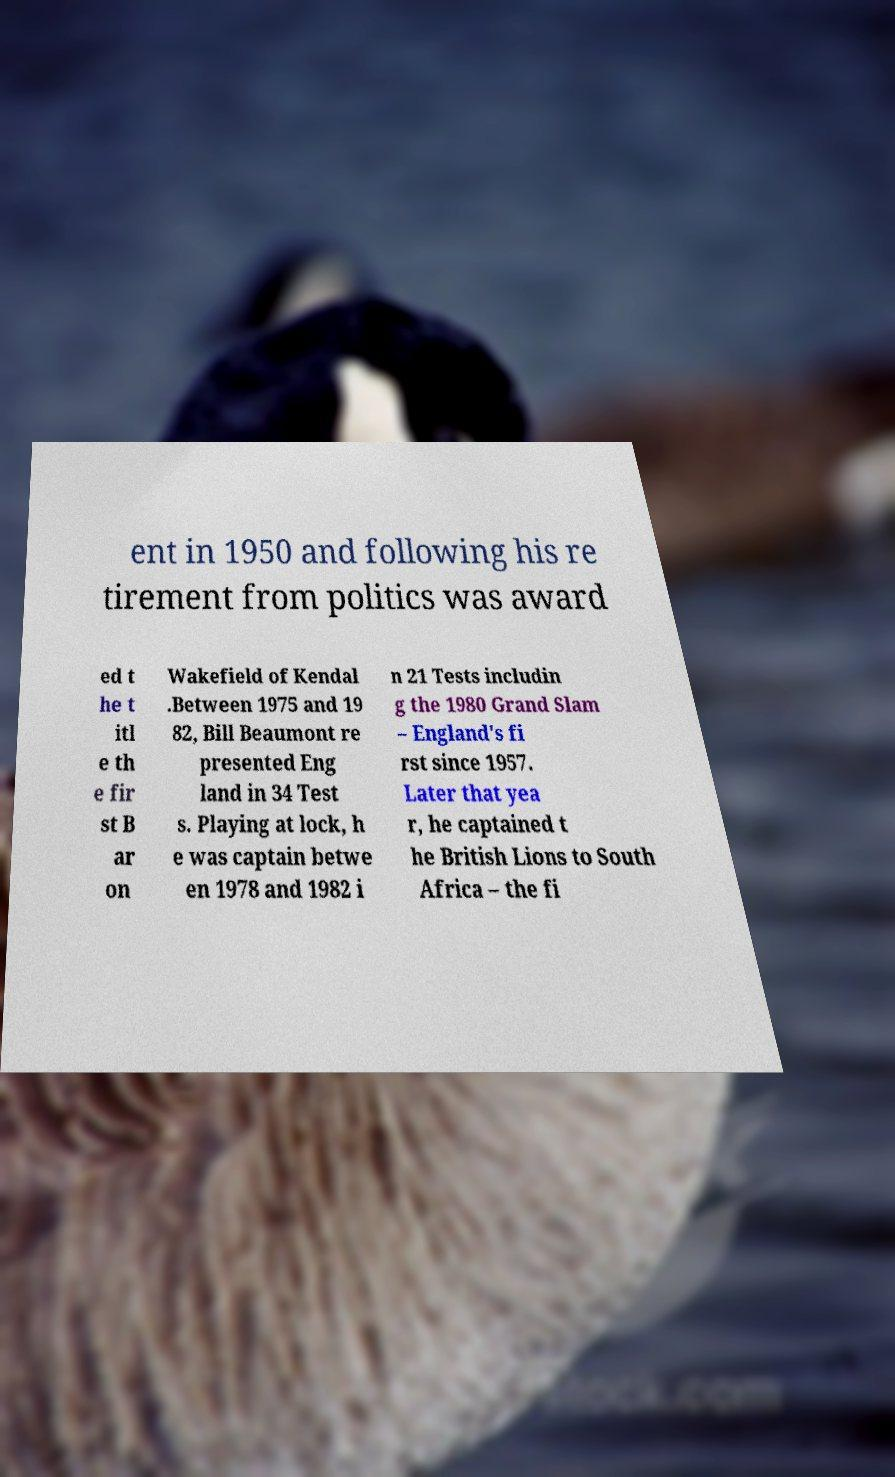For documentation purposes, I need the text within this image transcribed. Could you provide that? ent in 1950 and following his re tirement from politics was award ed t he t itl e th e fir st B ar on Wakefield of Kendal .Between 1975 and 19 82, Bill Beaumont re presented Eng land in 34 Test s. Playing at lock, h e was captain betwe en 1978 and 1982 i n 21 Tests includin g the 1980 Grand Slam – England's fi rst since 1957. Later that yea r, he captained t he British Lions to South Africa – the fi 